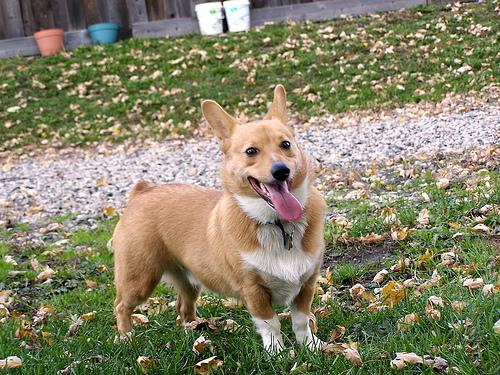Identify the breed of the dog in the image. The dog in the image is a Pembroke Welsh Corgi. This breed is characterized by its short legs, long body, and erect ears. Pembroke Welsh Corgis have a double coat, with the outer coat being longer and thicker. The coloration of the dog in the photo is consistent with common Corgi markings, featuring a tan or fawn color with white markings. Identifying dog breeds can usually be done by analyzing physical characteristics such as body shape, coat, and color patterns, as well as ear and head shape, which are distinctive in Corgis. This breed is known for being affectionate, smart, and alert, which seems to be reflected in the dog's attentive and happy expression. 